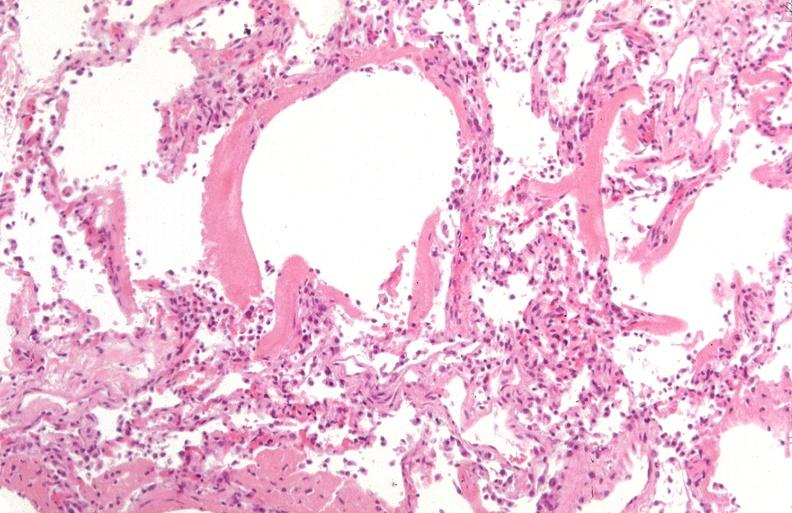s syndactyly present?
Answer the question using a single word or phrase. No 